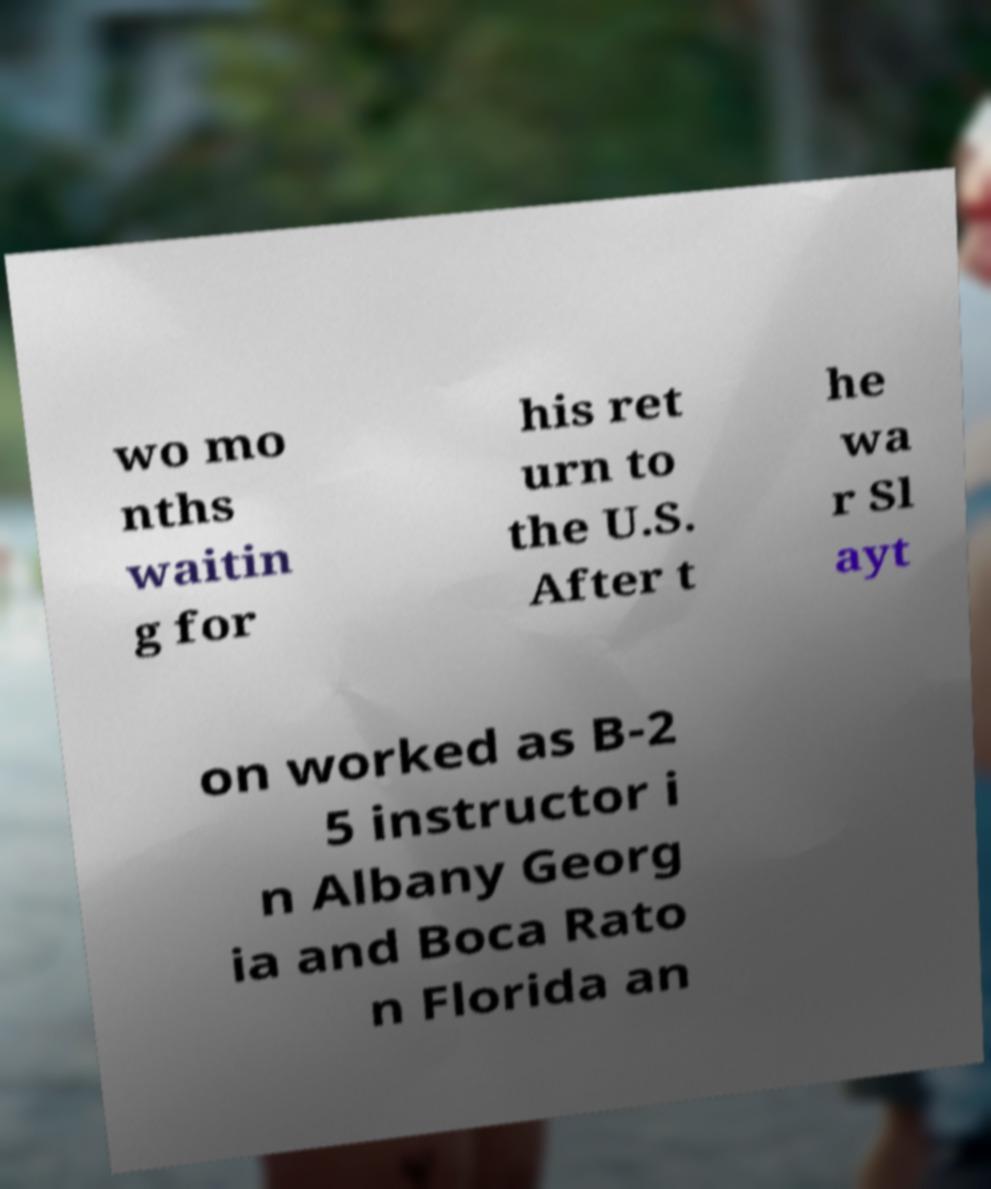Please identify and transcribe the text found in this image. wo mo nths waitin g for his ret urn to the U.S. After t he wa r Sl ayt on worked as B-2 5 instructor i n Albany Georg ia and Boca Rato n Florida an 